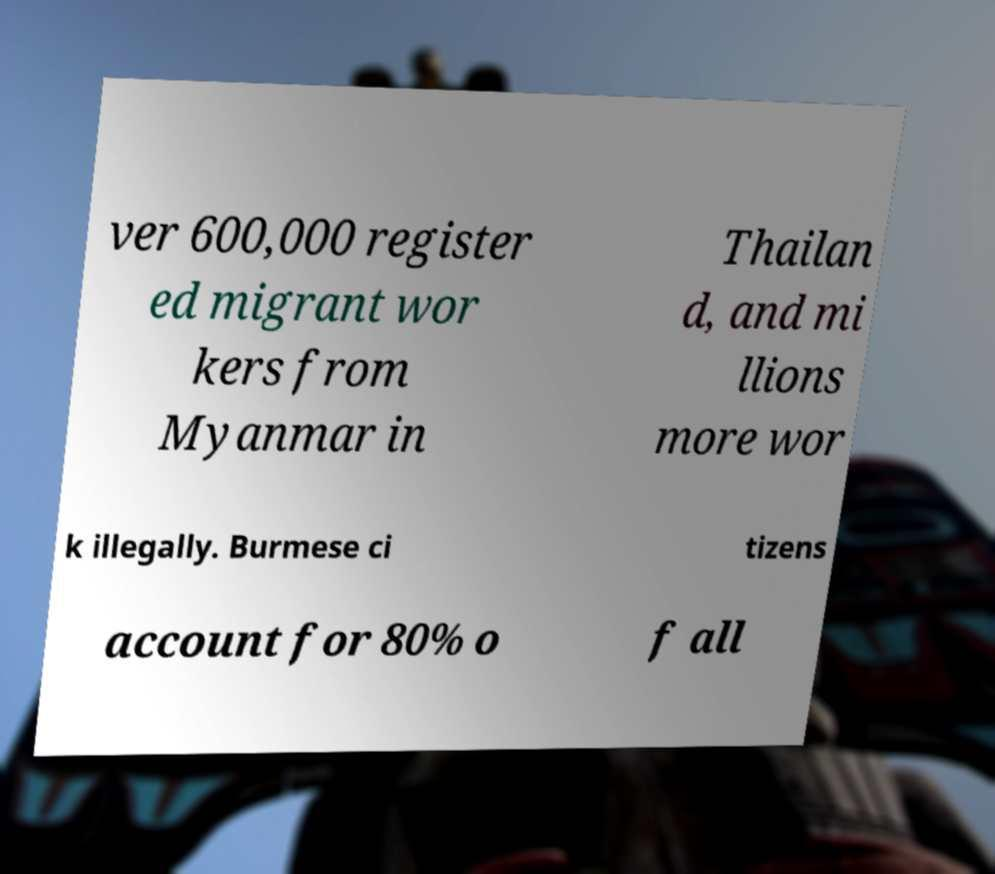What messages or text are displayed in this image? I need them in a readable, typed format. ver 600,000 register ed migrant wor kers from Myanmar in Thailan d, and mi llions more wor k illegally. Burmese ci tizens account for 80% o f all 